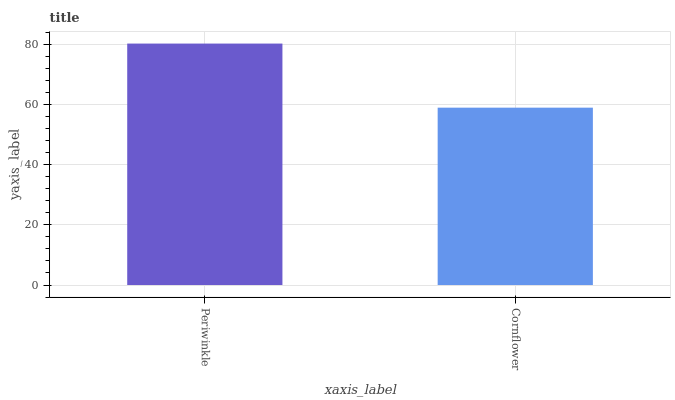Is Cornflower the minimum?
Answer yes or no. Yes. Is Periwinkle the maximum?
Answer yes or no. Yes. Is Cornflower the maximum?
Answer yes or no. No. Is Periwinkle greater than Cornflower?
Answer yes or no. Yes. Is Cornflower less than Periwinkle?
Answer yes or no. Yes. Is Cornflower greater than Periwinkle?
Answer yes or no. No. Is Periwinkle less than Cornflower?
Answer yes or no. No. Is Periwinkle the high median?
Answer yes or no. Yes. Is Cornflower the low median?
Answer yes or no. Yes. Is Cornflower the high median?
Answer yes or no. No. Is Periwinkle the low median?
Answer yes or no. No. 